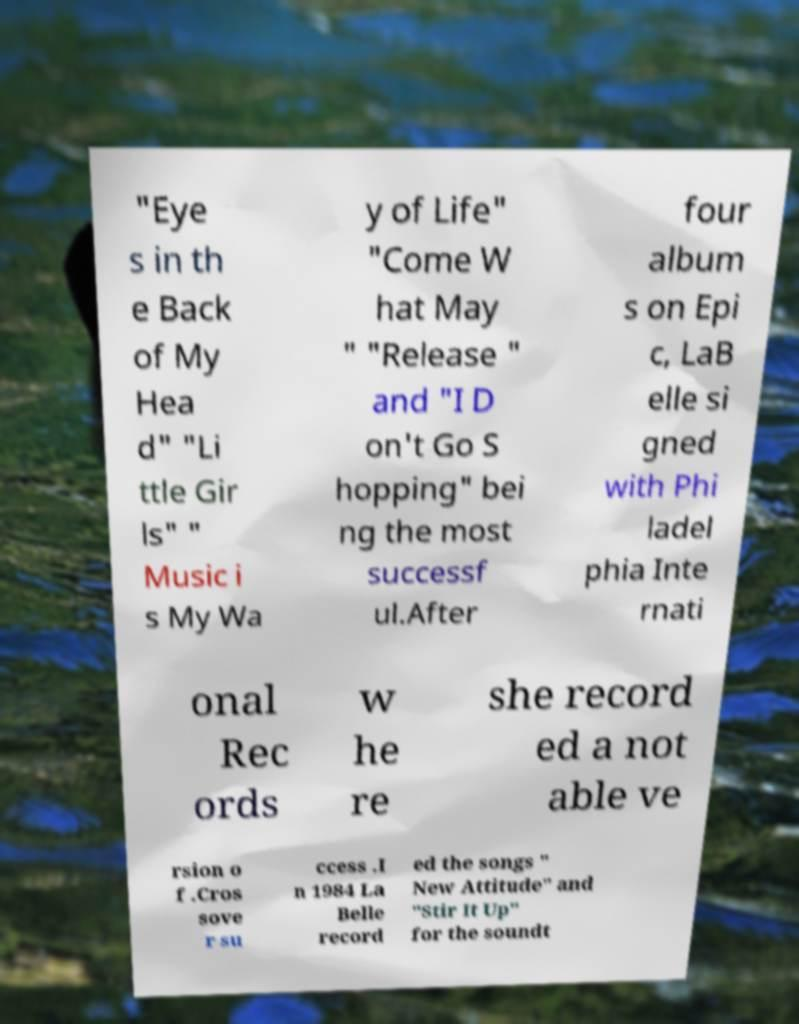Could you extract and type out the text from this image? "Eye s in th e Back of My Hea d" "Li ttle Gir ls" " Music i s My Wa y of Life" "Come W hat May " "Release " and "I D on't Go S hopping" bei ng the most successf ul.After four album s on Epi c, LaB elle si gned with Phi ladel phia Inte rnati onal Rec ords w he re she record ed a not able ve rsion o f .Cros sove r su ccess .I n 1984 La Belle record ed the songs " New Attitude" and "Stir It Up" for the soundt 